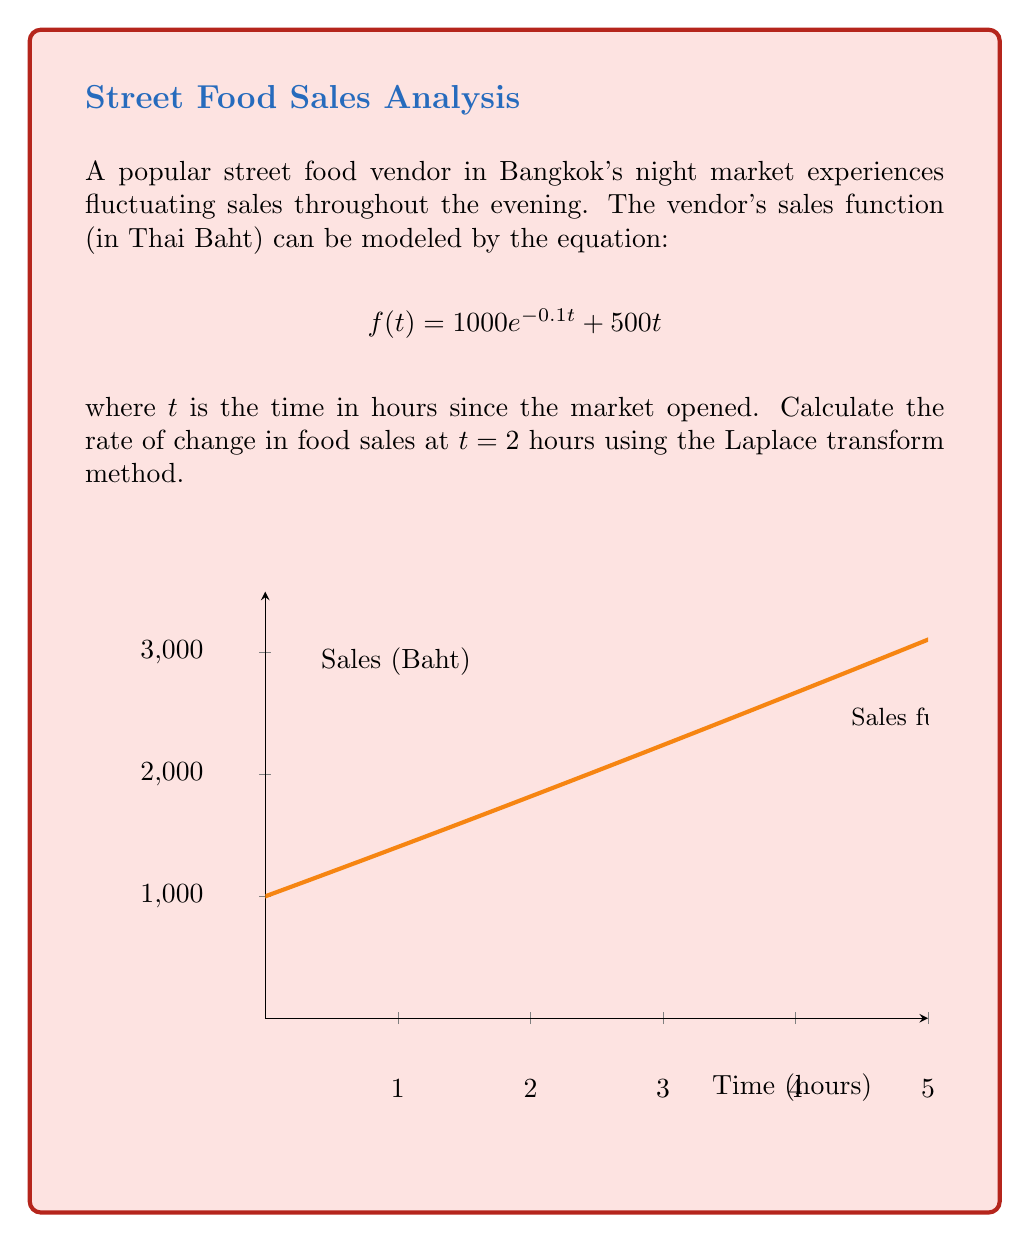Could you help me with this problem? To solve this problem using Laplace transforms, we'll follow these steps:

1) First, let's take the Laplace transform of $f(t)$:
   $$\mathcal{L}\{f(t)\} = \mathcal{L}\{1000e^{-0.1t} + 500t\}$$

2) Using linearity property:
   $$\mathcal{L}\{f(t)\} = 1000\mathcal{L}\{e^{-0.1t}\} + 500\mathcal{L}\{t\}$$

3) Using Laplace transform properties:
   $$F(s) = \frac{1000}{s+0.1} + \frac{500}{s^2}$$

4) To find the rate of change, we need to differentiate $f(t)$. In Laplace domain, this is equivalent to multiplying $F(s)$ by $s$ and subtracting the initial value $f(0)$:
   $$\mathcal{L}\{f'(t)\} = sF(s) - f(0) = s(\frac{1000}{s+0.1} + \frac{500}{s^2}) - 1000$$

5) Simplify:
   $$\mathcal{L}\{f'(t)\} = \frac{1000s}{s+0.1} + \frac{500}{s} - 1000$$

6) Now, we need to find the inverse Laplace transform:
   $$f'(t) = 1000e^{-0.1t} \cdot (-0.1) + 500$$

7) Evaluate at $t = 2$:
   $$f'(2) = 1000e^{-0.2} \cdot (-0.1) + 500$$

8) Calculate the final value:
   $$f'(2) = -81.87 + 500 = 418.13$$
Answer: $418.13$ Baht per hour 